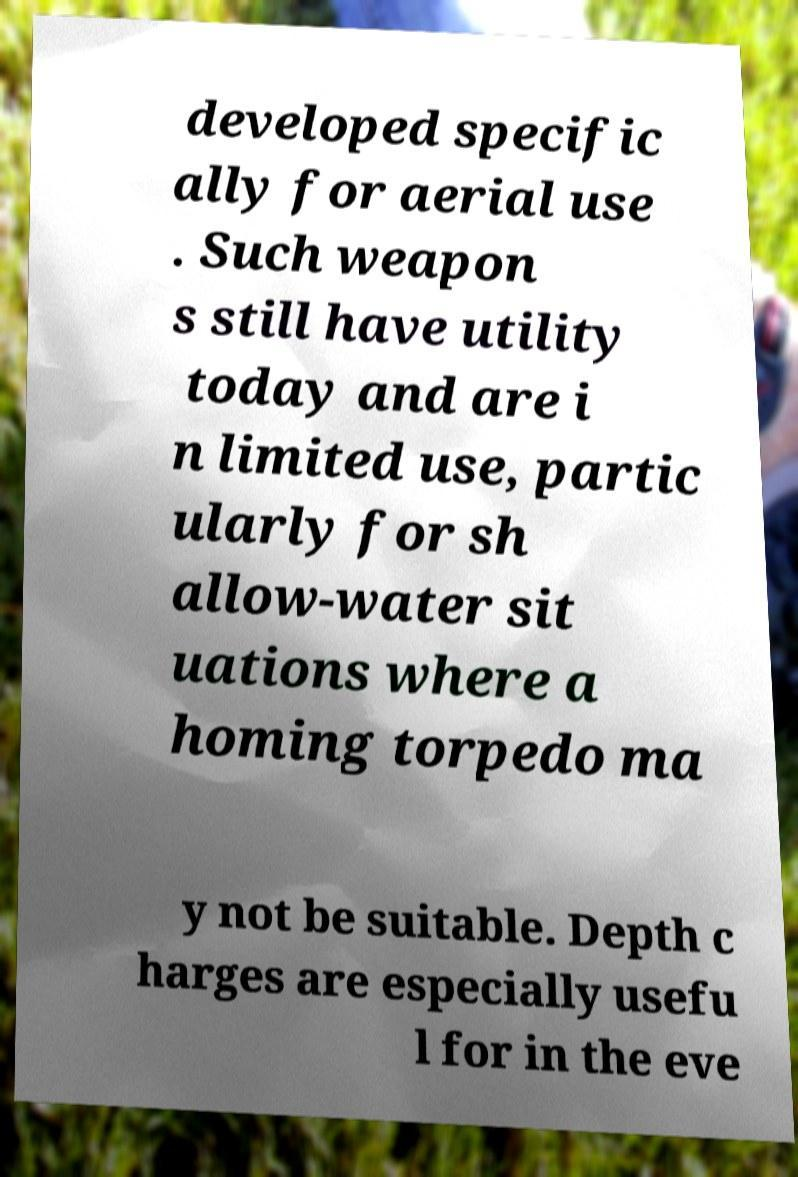I need the written content from this picture converted into text. Can you do that? developed specific ally for aerial use . Such weapon s still have utility today and are i n limited use, partic ularly for sh allow-water sit uations where a homing torpedo ma y not be suitable. Depth c harges are especially usefu l for in the eve 